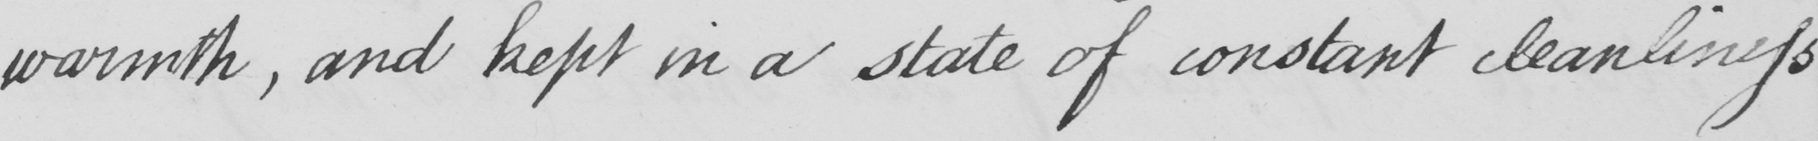Please transcribe the handwritten text in this image. warmth, and kept in a state of constant cleanliness 